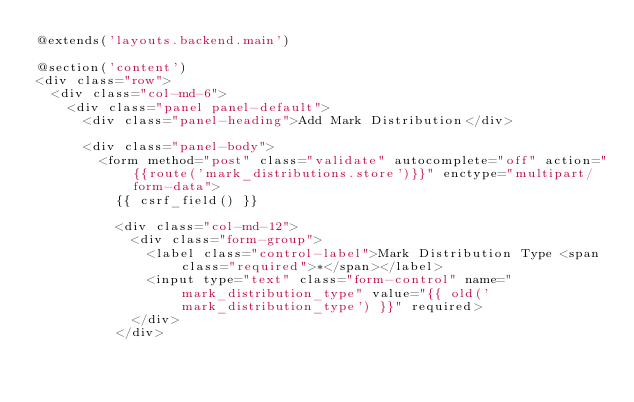<code> <loc_0><loc_0><loc_500><loc_500><_PHP_>@extends('layouts.backend.main')

@section('content')
<div class="row">
	<div class="col-md-6">
		<div class="panel panel-default">
			<div class="panel-heading">Add Mark Distribution</div>

			<div class="panel-body">
				<form method="post" class="validate" autocomplete="off" action="{{route('mark_distributions.store')}}" enctype="multipart/form-data">
					{{ csrf_field() }}

					<div class="col-md-12">
						<div class="form-group">
							<label class="control-label">Mark Distribution Type <span class="required">*</span></label>
							<input type="text" class="form-control" name="mark_distribution_type" value="{{ old('mark_distribution_type') }}" required>
						</div>
					</div>
</code> 